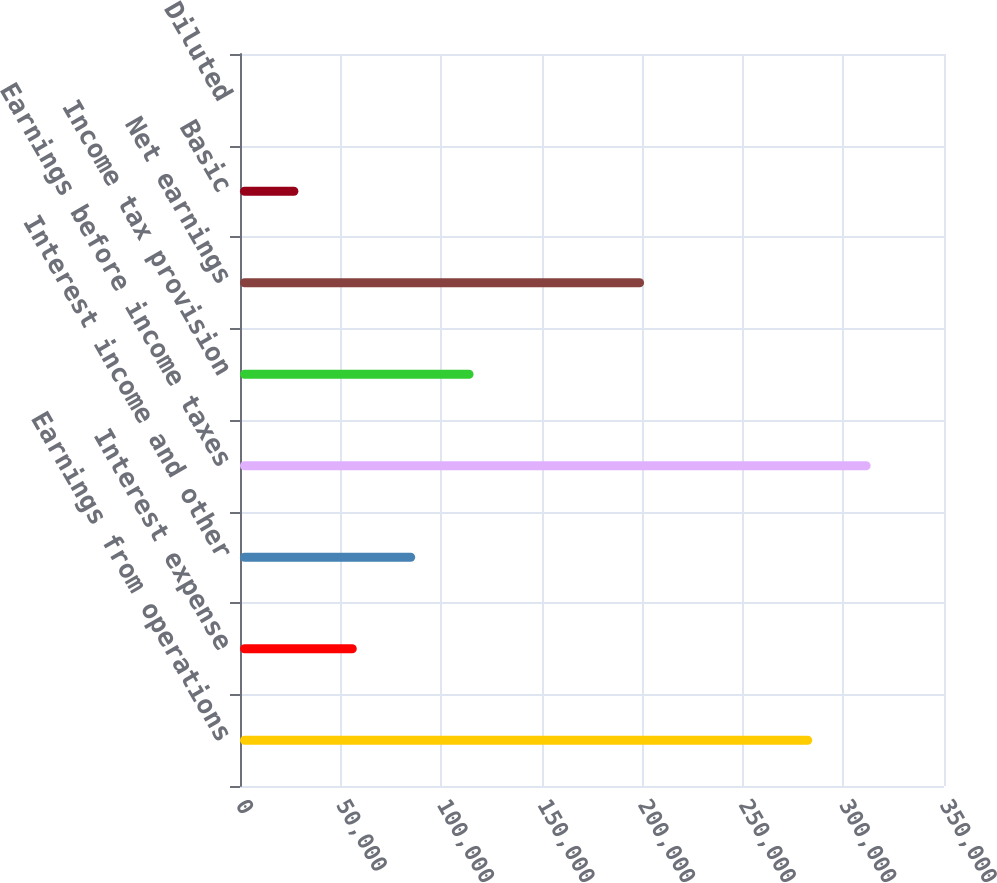<chart> <loc_0><loc_0><loc_500><loc_500><bar_chart><fcel>Earnings from operations<fcel>Interest expense<fcel>Interest income and other<fcel>Earnings before income taxes<fcel>Income tax provision<fcel>Net earnings<fcel>Basic<fcel>Diluted<nl><fcel>284491<fcel>58064.6<fcel>87096.3<fcel>313523<fcel>116128<fcel>200900<fcel>29033<fcel>1.28<nl></chart> 